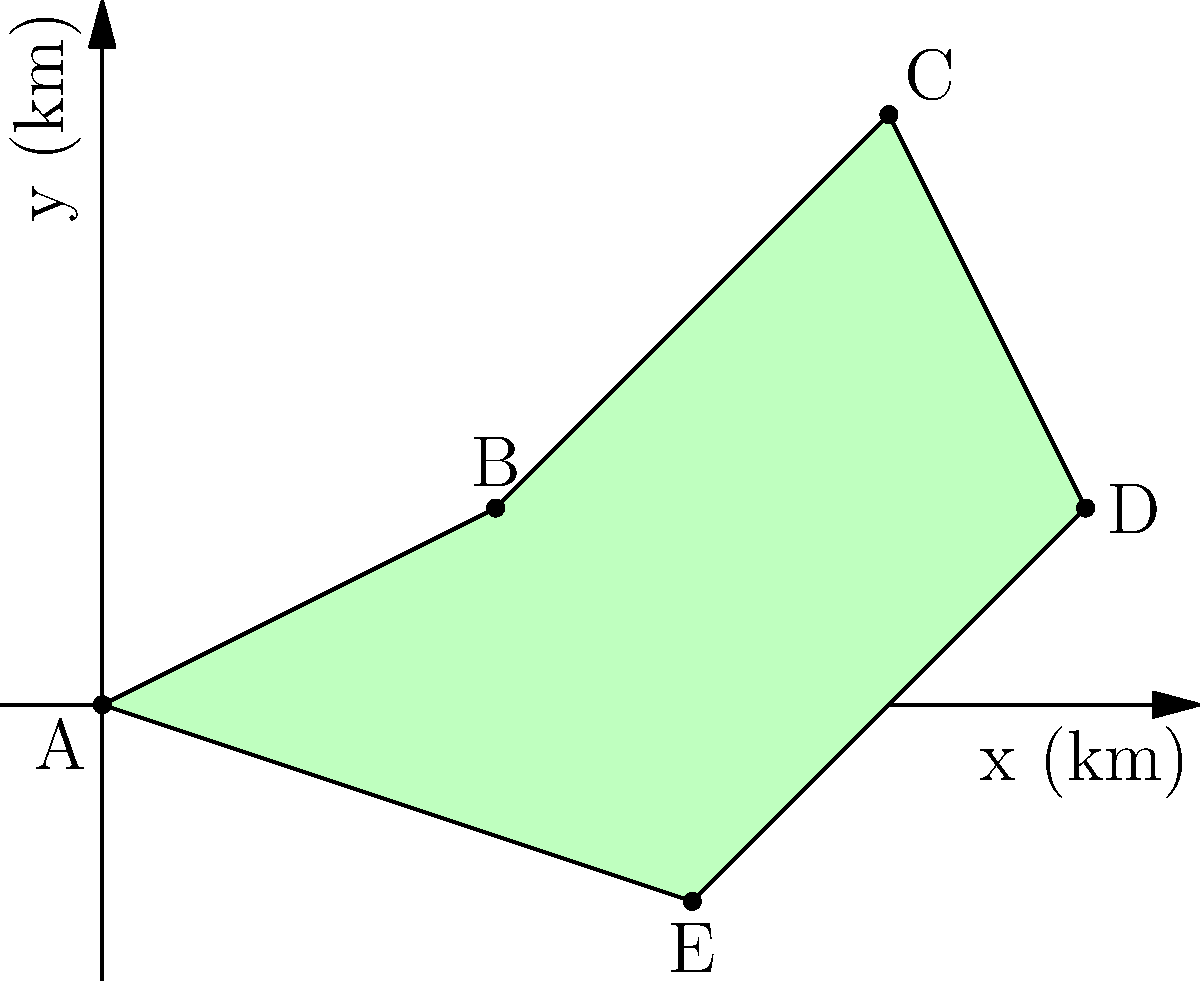A satellite image of an irregularly shaped nature reserve is shown above. The coordinates of the vertices are A(0,0), B(2,1), C(4,3), D(5,1), and E(3,-1) in kilometers. Calculate the area of the nature reserve using the shoelace formula. To calculate the area of this irregular polygon using the shoelace formula, we'll follow these steps:

1) The shoelace formula for a polygon with vertices $(x_1, y_1), (x_2, y_2), ..., (x_n, y_n)$ is:

   Area = $\frac{1}{2}|((x_1y_2 + x_2y_3 + ... + x_ny_1) - (y_1x_2 + y_2x_3 + ... + y_nx_1))|$

2) Let's organize our vertices:
   A(0,0), B(2,1), C(4,3), D(5,1), E(3,-1)

3) Now, let's apply the formula:

   $\frac{1}{2}|((0\cdot1 + 2\cdot3 + 4\cdot1 + 5\cdot(-1) + 3\cdot0) - (0\cdot2 + 1\cdot4 + 3\cdot5 + 1\cdot3 + (-1)\cdot0))|$

4) Simplify:
   $\frac{1}{2}|((0 + 6 + 4 - 5 + 0) - (0 + 4 + 15 + 3 + 0))|$

5) Calculate:
   $\frac{1}{2}|(5 - 22)|$
   $\frac{1}{2}|-17|$
   $\frac{1}{2}(17)$

6) Final result:
   Area = 8.5 sq km
Answer: 8.5 sq km 